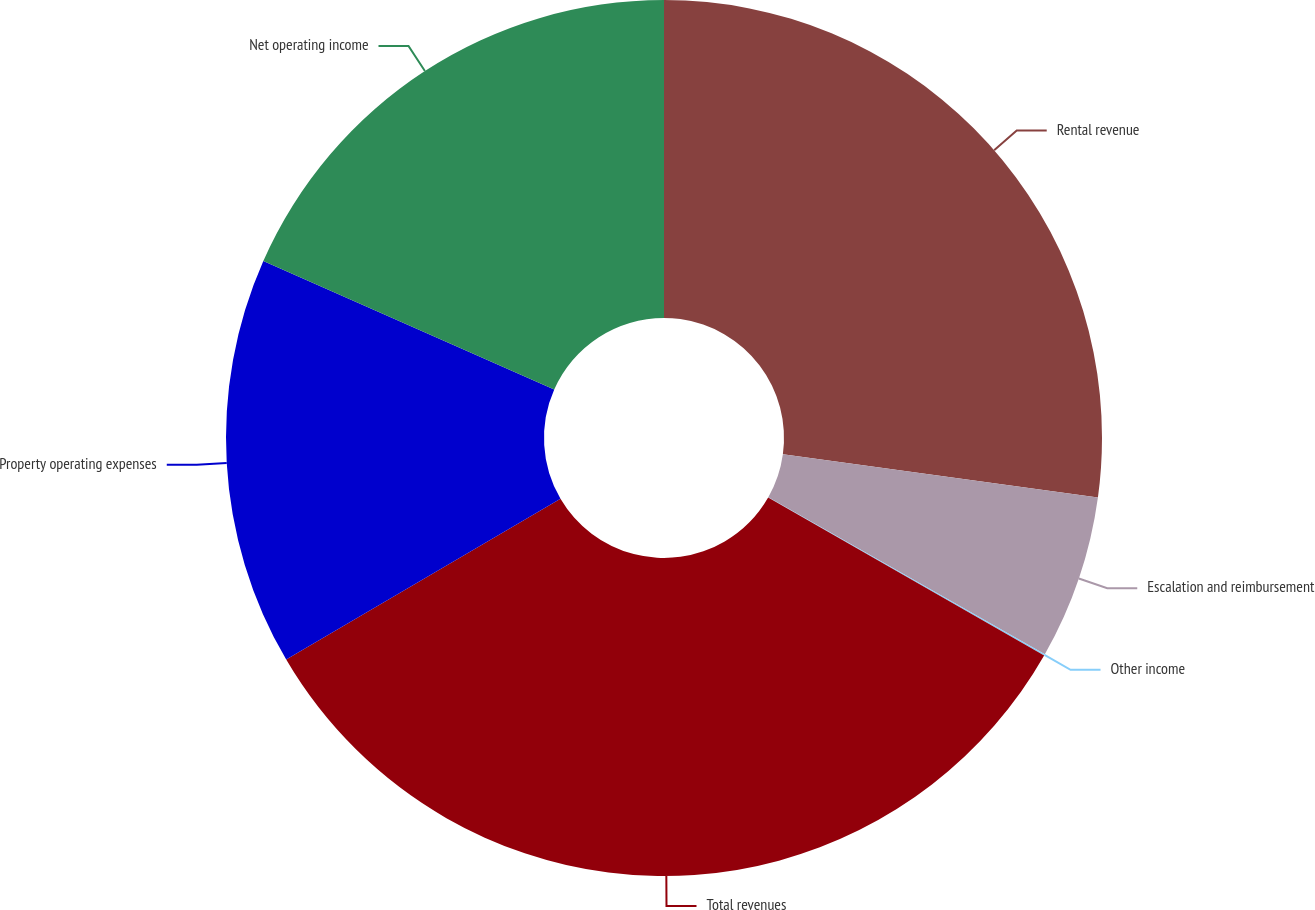Convert chart. <chart><loc_0><loc_0><loc_500><loc_500><pie_chart><fcel>Rental revenue<fcel>Escalation and reimbursement<fcel>Other income<fcel>Total revenues<fcel>Property operating expenses<fcel>Net operating income<nl><fcel>27.17%<fcel>6.05%<fcel>0.05%<fcel>33.28%<fcel>15.06%<fcel>18.38%<nl></chart> 